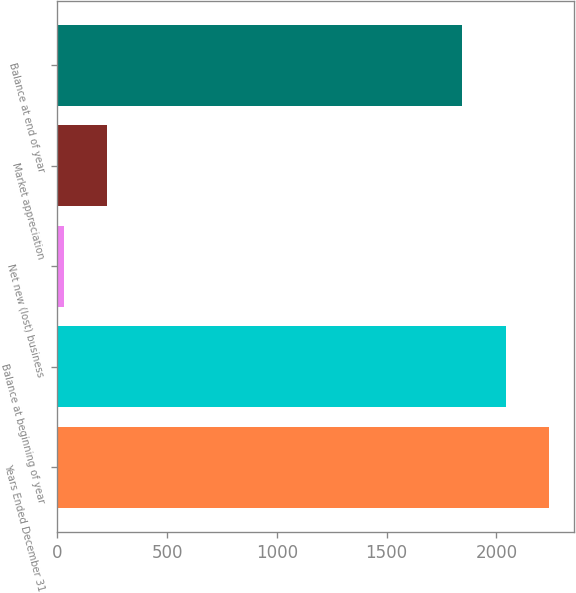<chart> <loc_0><loc_0><loc_500><loc_500><bar_chart><fcel>Years Ended December 31<fcel>Balance at beginning of year<fcel>Net new (lost) business<fcel>Market appreciation<fcel>Balance at end of year<nl><fcel>2241.2<fcel>2043.1<fcel>30<fcel>228.1<fcel>1845<nl></chart> 